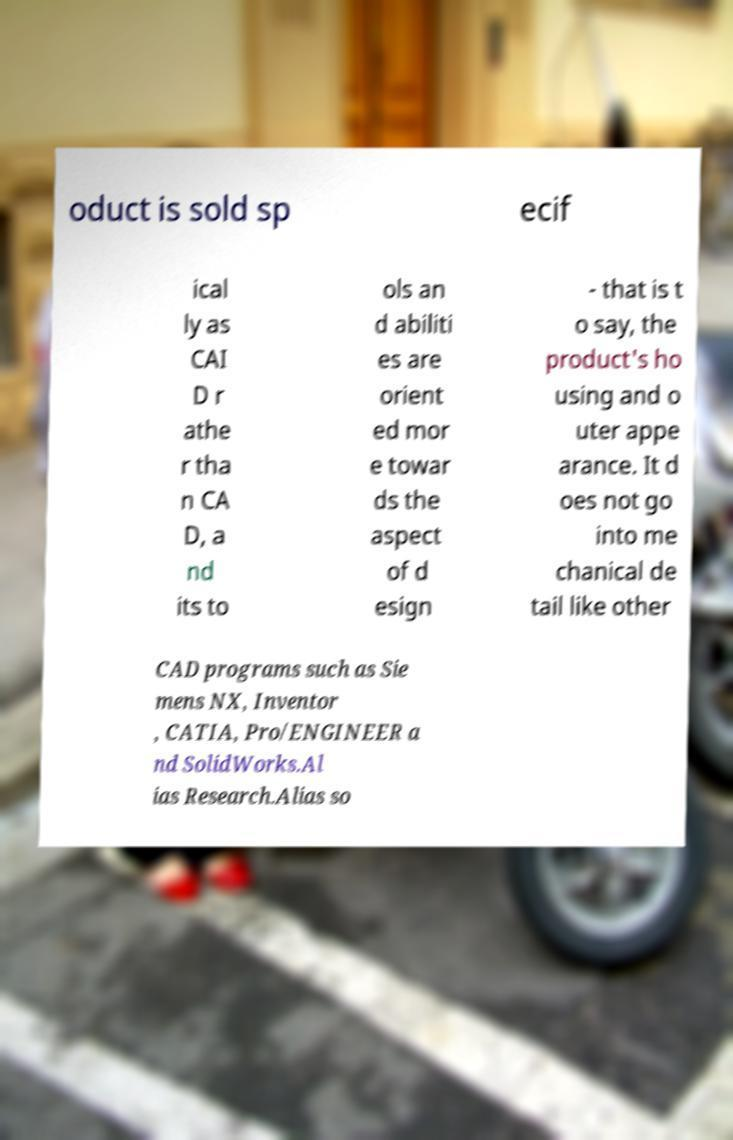Could you assist in decoding the text presented in this image and type it out clearly? oduct is sold sp ecif ical ly as CAI D r athe r tha n CA D, a nd its to ols an d abiliti es are orient ed mor e towar ds the aspect of d esign - that is t o say, the product's ho using and o uter appe arance. It d oes not go into me chanical de tail like other CAD programs such as Sie mens NX, Inventor , CATIA, Pro/ENGINEER a nd SolidWorks.Al ias Research.Alias so 